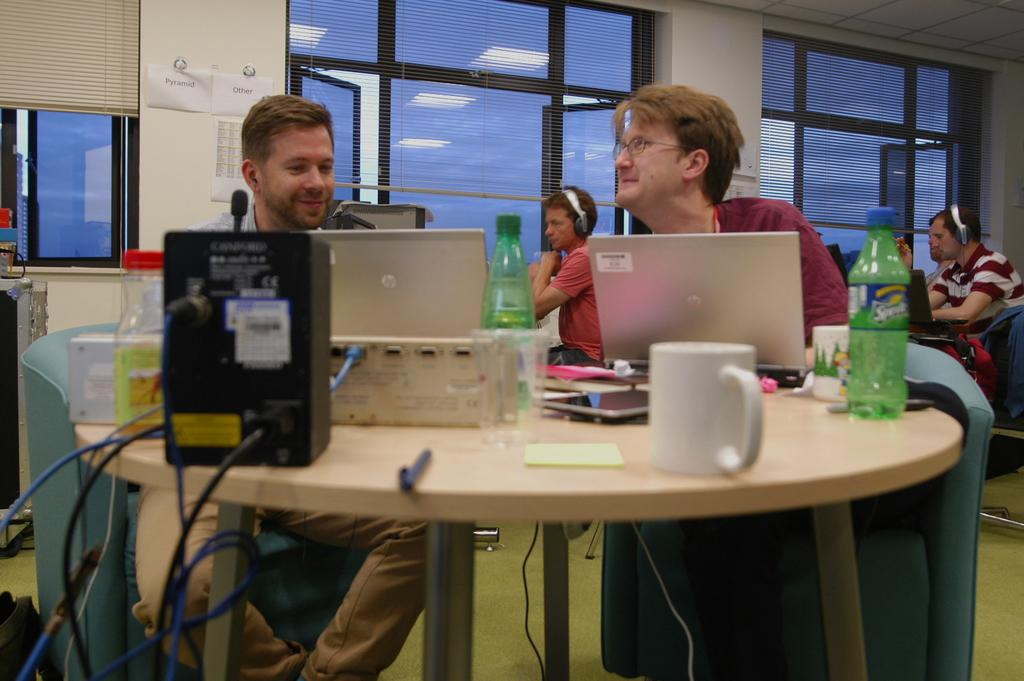What is the main activity of the people in the image? The people in the image are working on laptops. Where are the people seated in the image? The people are seated at a table. What objects are on the table with the people? There is a bottle and cups on the table. What type of beetle can be seen crawling on the stem of the faucet in the image? There is no beetle or faucet present in the image. 